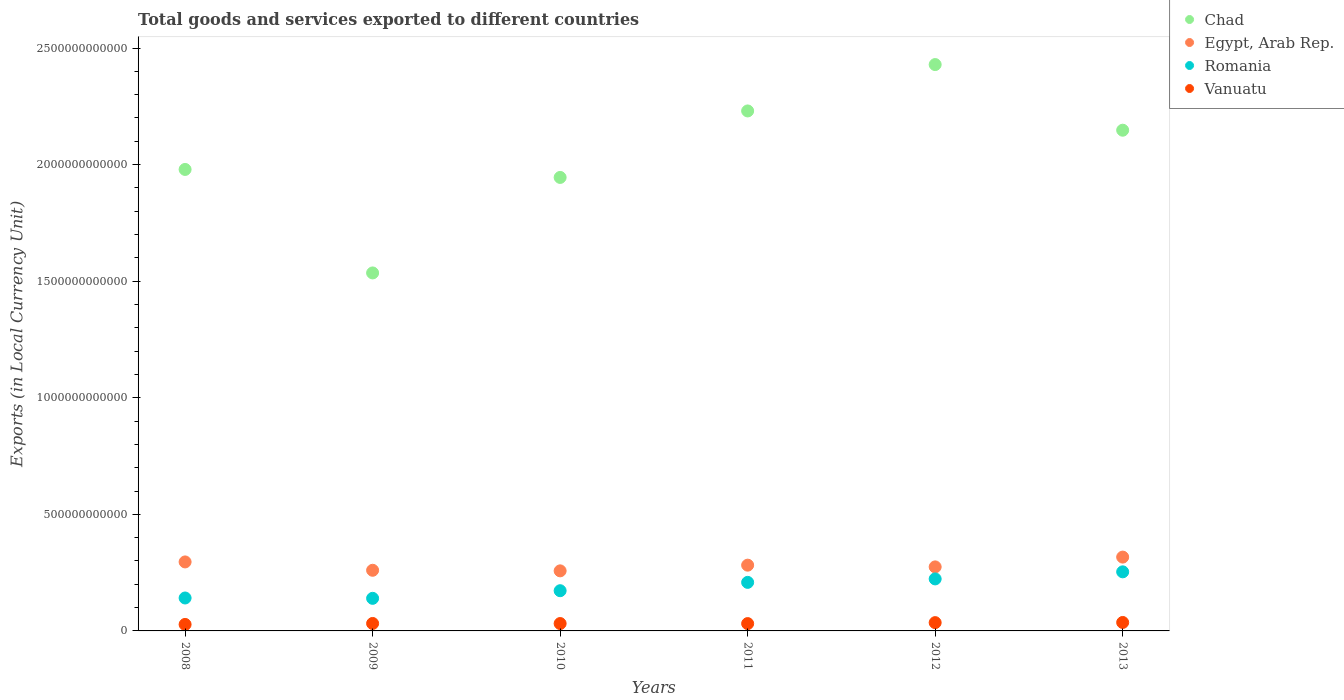How many different coloured dotlines are there?
Provide a succinct answer. 4. What is the Amount of goods and services exports in Vanuatu in 2011?
Make the answer very short. 3.14e+1. Across all years, what is the maximum Amount of goods and services exports in Egypt, Arab Rep.?
Offer a very short reply. 3.17e+11. Across all years, what is the minimum Amount of goods and services exports in Vanuatu?
Provide a succinct answer. 2.78e+1. What is the total Amount of goods and services exports in Vanuatu in the graph?
Keep it short and to the point. 1.95e+11. What is the difference between the Amount of goods and services exports in Chad in 2009 and that in 2010?
Offer a terse response. -4.10e+11. What is the difference between the Amount of goods and services exports in Egypt, Arab Rep. in 2010 and the Amount of goods and services exports in Chad in 2009?
Your answer should be compact. -1.28e+12. What is the average Amount of goods and services exports in Vanuatu per year?
Make the answer very short. 3.24e+1. In the year 2009, what is the difference between the Amount of goods and services exports in Romania and Amount of goods and services exports in Vanuatu?
Give a very brief answer. 1.08e+11. In how many years, is the Amount of goods and services exports in Vanuatu greater than 2200000000000 LCU?
Provide a short and direct response. 0. What is the ratio of the Amount of goods and services exports in Egypt, Arab Rep. in 2012 to that in 2013?
Make the answer very short. 0.87. Is the Amount of goods and services exports in Romania in 2009 less than that in 2010?
Provide a succinct answer. Yes. Is the difference between the Amount of goods and services exports in Romania in 2008 and 2010 greater than the difference between the Amount of goods and services exports in Vanuatu in 2008 and 2010?
Your answer should be very brief. No. What is the difference between the highest and the second highest Amount of goods and services exports in Vanuatu?
Make the answer very short. 7.05e+08. What is the difference between the highest and the lowest Amount of goods and services exports in Egypt, Arab Rep.?
Your answer should be compact. 5.90e+1. In how many years, is the Amount of goods and services exports in Romania greater than the average Amount of goods and services exports in Romania taken over all years?
Your response must be concise. 3. Is the sum of the Amount of goods and services exports in Romania in 2011 and 2013 greater than the maximum Amount of goods and services exports in Vanuatu across all years?
Ensure brevity in your answer.  Yes. Is it the case that in every year, the sum of the Amount of goods and services exports in Egypt, Arab Rep. and Amount of goods and services exports in Chad  is greater than the sum of Amount of goods and services exports in Vanuatu and Amount of goods and services exports in Romania?
Give a very brief answer. Yes. Is it the case that in every year, the sum of the Amount of goods and services exports in Romania and Amount of goods and services exports in Vanuatu  is greater than the Amount of goods and services exports in Egypt, Arab Rep.?
Your response must be concise. No. Does the Amount of goods and services exports in Vanuatu monotonically increase over the years?
Provide a succinct answer. No. What is the difference between two consecutive major ticks on the Y-axis?
Ensure brevity in your answer.  5.00e+11. Does the graph contain grids?
Give a very brief answer. No. Where does the legend appear in the graph?
Provide a short and direct response. Top right. How many legend labels are there?
Keep it short and to the point. 4. What is the title of the graph?
Ensure brevity in your answer.  Total goods and services exported to different countries. Does "South Asia" appear as one of the legend labels in the graph?
Ensure brevity in your answer.  No. What is the label or title of the Y-axis?
Ensure brevity in your answer.  Exports (in Local Currency Unit). What is the Exports (in Local Currency Unit) of Chad in 2008?
Offer a very short reply. 1.98e+12. What is the Exports (in Local Currency Unit) in Egypt, Arab Rep. in 2008?
Make the answer very short. 2.96e+11. What is the Exports (in Local Currency Unit) of Romania in 2008?
Provide a short and direct response. 1.41e+11. What is the Exports (in Local Currency Unit) of Vanuatu in 2008?
Ensure brevity in your answer.  2.78e+1. What is the Exports (in Local Currency Unit) in Chad in 2009?
Provide a succinct answer. 1.54e+12. What is the Exports (in Local Currency Unit) of Egypt, Arab Rep. in 2009?
Give a very brief answer. 2.60e+11. What is the Exports (in Local Currency Unit) of Romania in 2009?
Offer a terse response. 1.40e+11. What is the Exports (in Local Currency Unit) of Vanuatu in 2009?
Offer a very short reply. 3.20e+1. What is the Exports (in Local Currency Unit) of Chad in 2010?
Your response must be concise. 1.94e+12. What is the Exports (in Local Currency Unit) of Egypt, Arab Rep. in 2010?
Offer a terse response. 2.58e+11. What is the Exports (in Local Currency Unit) of Romania in 2010?
Your answer should be compact. 1.72e+11. What is the Exports (in Local Currency Unit) of Vanuatu in 2010?
Keep it short and to the point. 3.17e+1. What is the Exports (in Local Currency Unit) of Chad in 2011?
Offer a terse response. 2.23e+12. What is the Exports (in Local Currency Unit) of Egypt, Arab Rep. in 2011?
Give a very brief answer. 2.82e+11. What is the Exports (in Local Currency Unit) in Romania in 2011?
Make the answer very short. 2.08e+11. What is the Exports (in Local Currency Unit) of Vanuatu in 2011?
Keep it short and to the point. 3.14e+1. What is the Exports (in Local Currency Unit) of Chad in 2012?
Offer a terse response. 2.43e+12. What is the Exports (in Local Currency Unit) in Egypt, Arab Rep. in 2012?
Keep it short and to the point. 2.75e+11. What is the Exports (in Local Currency Unit) of Romania in 2012?
Make the answer very short. 2.23e+11. What is the Exports (in Local Currency Unit) in Vanuatu in 2012?
Give a very brief answer. 3.55e+1. What is the Exports (in Local Currency Unit) in Chad in 2013?
Provide a short and direct response. 2.15e+12. What is the Exports (in Local Currency Unit) of Egypt, Arab Rep. in 2013?
Offer a terse response. 3.17e+11. What is the Exports (in Local Currency Unit) in Romania in 2013?
Give a very brief answer. 2.53e+11. What is the Exports (in Local Currency Unit) in Vanuatu in 2013?
Provide a short and direct response. 3.63e+1. Across all years, what is the maximum Exports (in Local Currency Unit) of Chad?
Provide a succinct answer. 2.43e+12. Across all years, what is the maximum Exports (in Local Currency Unit) in Egypt, Arab Rep.?
Provide a succinct answer. 3.17e+11. Across all years, what is the maximum Exports (in Local Currency Unit) of Romania?
Offer a very short reply. 2.53e+11. Across all years, what is the maximum Exports (in Local Currency Unit) of Vanuatu?
Offer a very short reply. 3.63e+1. Across all years, what is the minimum Exports (in Local Currency Unit) in Chad?
Give a very brief answer. 1.54e+12. Across all years, what is the minimum Exports (in Local Currency Unit) of Egypt, Arab Rep.?
Your answer should be compact. 2.58e+11. Across all years, what is the minimum Exports (in Local Currency Unit) in Romania?
Provide a short and direct response. 1.40e+11. Across all years, what is the minimum Exports (in Local Currency Unit) in Vanuatu?
Make the answer very short. 2.78e+1. What is the total Exports (in Local Currency Unit) in Chad in the graph?
Ensure brevity in your answer.  1.23e+13. What is the total Exports (in Local Currency Unit) of Egypt, Arab Rep. in the graph?
Your answer should be very brief. 1.69e+12. What is the total Exports (in Local Currency Unit) of Romania in the graph?
Offer a terse response. 1.14e+12. What is the total Exports (in Local Currency Unit) of Vanuatu in the graph?
Provide a succinct answer. 1.95e+11. What is the difference between the Exports (in Local Currency Unit) in Chad in 2008 and that in 2009?
Give a very brief answer. 4.44e+11. What is the difference between the Exports (in Local Currency Unit) of Egypt, Arab Rep. in 2008 and that in 2009?
Your answer should be very brief. 3.58e+1. What is the difference between the Exports (in Local Currency Unit) in Romania in 2008 and that in 2009?
Your answer should be very brief. 1.50e+09. What is the difference between the Exports (in Local Currency Unit) in Vanuatu in 2008 and that in 2009?
Your answer should be very brief. -4.16e+09. What is the difference between the Exports (in Local Currency Unit) in Chad in 2008 and that in 2010?
Provide a succinct answer. 3.43e+1. What is the difference between the Exports (in Local Currency Unit) in Egypt, Arab Rep. in 2008 and that in 2010?
Give a very brief answer. 3.83e+1. What is the difference between the Exports (in Local Currency Unit) of Romania in 2008 and that in 2010?
Keep it short and to the point. -3.12e+1. What is the difference between the Exports (in Local Currency Unit) in Vanuatu in 2008 and that in 2010?
Offer a terse response. -3.84e+09. What is the difference between the Exports (in Local Currency Unit) in Chad in 2008 and that in 2011?
Your response must be concise. -2.51e+11. What is the difference between the Exports (in Local Currency Unit) of Egypt, Arab Rep. in 2008 and that in 2011?
Keep it short and to the point. 1.39e+1. What is the difference between the Exports (in Local Currency Unit) of Romania in 2008 and that in 2011?
Offer a terse response. -6.70e+1. What is the difference between the Exports (in Local Currency Unit) in Vanuatu in 2008 and that in 2011?
Provide a short and direct response. -3.60e+09. What is the difference between the Exports (in Local Currency Unit) in Chad in 2008 and that in 2012?
Keep it short and to the point. -4.50e+11. What is the difference between the Exports (in Local Currency Unit) in Egypt, Arab Rep. in 2008 and that in 2012?
Your answer should be very brief. 2.13e+1. What is the difference between the Exports (in Local Currency Unit) in Romania in 2008 and that in 2012?
Your answer should be compact. -8.18e+1. What is the difference between the Exports (in Local Currency Unit) in Vanuatu in 2008 and that in 2012?
Keep it short and to the point. -7.72e+09. What is the difference between the Exports (in Local Currency Unit) in Chad in 2008 and that in 2013?
Offer a terse response. -1.68e+11. What is the difference between the Exports (in Local Currency Unit) in Egypt, Arab Rep. in 2008 and that in 2013?
Your answer should be very brief. -2.07e+1. What is the difference between the Exports (in Local Currency Unit) in Romania in 2008 and that in 2013?
Give a very brief answer. -1.12e+11. What is the difference between the Exports (in Local Currency Unit) in Vanuatu in 2008 and that in 2013?
Keep it short and to the point. -8.43e+09. What is the difference between the Exports (in Local Currency Unit) in Chad in 2009 and that in 2010?
Ensure brevity in your answer.  -4.10e+11. What is the difference between the Exports (in Local Currency Unit) in Egypt, Arab Rep. in 2009 and that in 2010?
Make the answer very short. 2.50e+09. What is the difference between the Exports (in Local Currency Unit) of Romania in 2009 and that in 2010?
Keep it short and to the point. -3.27e+1. What is the difference between the Exports (in Local Currency Unit) in Vanuatu in 2009 and that in 2010?
Provide a succinct answer. 3.15e+08. What is the difference between the Exports (in Local Currency Unit) of Chad in 2009 and that in 2011?
Ensure brevity in your answer.  -6.95e+11. What is the difference between the Exports (in Local Currency Unit) of Egypt, Arab Rep. in 2009 and that in 2011?
Provide a short and direct response. -2.19e+1. What is the difference between the Exports (in Local Currency Unit) in Romania in 2009 and that in 2011?
Make the answer very short. -6.85e+1. What is the difference between the Exports (in Local Currency Unit) in Vanuatu in 2009 and that in 2011?
Keep it short and to the point. 5.55e+08. What is the difference between the Exports (in Local Currency Unit) in Chad in 2009 and that in 2012?
Ensure brevity in your answer.  -8.94e+11. What is the difference between the Exports (in Local Currency Unit) in Egypt, Arab Rep. in 2009 and that in 2012?
Your response must be concise. -1.45e+1. What is the difference between the Exports (in Local Currency Unit) in Romania in 2009 and that in 2012?
Offer a very short reply. -8.33e+1. What is the difference between the Exports (in Local Currency Unit) of Vanuatu in 2009 and that in 2012?
Your response must be concise. -3.57e+09. What is the difference between the Exports (in Local Currency Unit) in Chad in 2009 and that in 2013?
Your answer should be very brief. -6.12e+11. What is the difference between the Exports (in Local Currency Unit) in Egypt, Arab Rep. in 2009 and that in 2013?
Provide a short and direct response. -5.65e+1. What is the difference between the Exports (in Local Currency Unit) of Romania in 2009 and that in 2013?
Give a very brief answer. -1.14e+11. What is the difference between the Exports (in Local Currency Unit) in Vanuatu in 2009 and that in 2013?
Offer a terse response. -4.27e+09. What is the difference between the Exports (in Local Currency Unit) of Chad in 2010 and that in 2011?
Offer a terse response. -2.85e+11. What is the difference between the Exports (in Local Currency Unit) in Egypt, Arab Rep. in 2010 and that in 2011?
Keep it short and to the point. -2.44e+1. What is the difference between the Exports (in Local Currency Unit) in Romania in 2010 and that in 2011?
Offer a terse response. -3.58e+1. What is the difference between the Exports (in Local Currency Unit) in Vanuatu in 2010 and that in 2011?
Provide a succinct answer. 2.40e+08. What is the difference between the Exports (in Local Currency Unit) of Chad in 2010 and that in 2012?
Your response must be concise. -4.84e+11. What is the difference between the Exports (in Local Currency Unit) of Egypt, Arab Rep. in 2010 and that in 2012?
Make the answer very short. -1.70e+1. What is the difference between the Exports (in Local Currency Unit) of Romania in 2010 and that in 2012?
Give a very brief answer. -5.06e+1. What is the difference between the Exports (in Local Currency Unit) of Vanuatu in 2010 and that in 2012?
Ensure brevity in your answer.  -3.88e+09. What is the difference between the Exports (in Local Currency Unit) of Chad in 2010 and that in 2013?
Make the answer very short. -2.03e+11. What is the difference between the Exports (in Local Currency Unit) of Egypt, Arab Rep. in 2010 and that in 2013?
Give a very brief answer. -5.90e+1. What is the difference between the Exports (in Local Currency Unit) of Romania in 2010 and that in 2013?
Give a very brief answer. -8.09e+1. What is the difference between the Exports (in Local Currency Unit) of Vanuatu in 2010 and that in 2013?
Provide a succinct answer. -4.59e+09. What is the difference between the Exports (in Local Currency Unit) in Chad in 2011 and that in 2012?
Offer a terse response. -1.99e+11. What is the difference between the Exports (in Local Currency Unit) of Egypt, Arab Rep. in 2011 and that in 2012?
Your response must be concise. 7.40e+09. What is the difference between the Exports (in Local Currency Unit) of Romania in 2011 and that in 2012?
Offer a very short reply. -1.48e+1. What is the difference between the Exports (in Local Currency Unit) of Vanuatu in 2011 and that in 2012?
Offer a very short reply. -4.12e+09. What is the difference between the Exports (in Local Currency Unit) of Chad in 2011 and that in 2013?
Your response must be concise. 8.26e+1. What is the difference between the Exports (in Local Currency Unit) of Egypt, Arab Rep. in 2011 and that in 2013?
Give a very brief answer. -3.46e+1. What is the difference between the Exports (in Local Currency Unit) of Romania in 2011 and that in 2013?
Offer a very short reply. -4.52e+1. What is the difference between the Exports (in Local Currency Unit) of Vanuatu in 2011 and that in 2013?
Give a very brief answer. -4.83e+09. What is the difference between the Exports (in Local Currency Unit) in Chad in 2012 and that in 2013?
Your answer should be very brief. 2.82e+11. What is the difference between the Exports (in Local Currency Unit) in Egypt, Arab Rep. in 2012 and that in 2013?
Give a very brief answer. -4.20e+1. What is the difference between the Exports (in Local Currency Unit) in Romania in 2012 and that in 2013?
Your response must be concise. -3.03e+1. What is the difference between the Exports (in Local Currency Unit) of Vanuatu in 2012 and that in 2013?
Provide a succinct answer. -7.05e+08. What is the difference between the Exports (in Local Currency Unit) in Chad in 2008 and the Exports (in Local Currency Unit) in Egypt, Arab Rep. in 2009?
Offer a terse response. 1.72e+12. What is the difference between the Exports (in Local Currency Unit) in Chad in 2008 and the Exports (in Local Currency Unit) in Romania in 2009?
Offer a terse response. 1.84e+12. What is the difference between the Exports (in Local Currency Unit) of Chad in 2008 and the Exports (in Local Currency Unit) of Vanuatu in 2009?
Offer a terse response. 1.95e+12. What is the difference between the Exports (in Local Currency Unit) of Egypt, Arab Rep. in 2008 and the Exports (in Local Currency Unit) of Romania in 2009?
Make the answer very short. 1.56e+11. What is the difference between the Exports (in Local Currency Unit) in Egypt, Arab Rep. in 2008 and the Exports (in Local Currency Unit) in Vanuatu in 2009?
Provide a succinct answer. 2.64e+11. What is the difference between the Exports (in Local Currency Unit) in Romania in 2008 and the Exports (in Local Currency Unit) in Vanuatu in 2009?
Give a very brief answer. 1.09e+11. What is the difference between the Exports (in Local Currency Unit) in Chad in 2008 and the Exports (in Local Currency Unit) in Egypt, Arab Rep. in 2010?
Your answer should be compact. 1.72e+12. What is the difference between the Exports (in Local Currency Unit) of Chad in 2008 and the Exports (in Local Currency Unit) of Romania in 2010?
Make the answer very short. 1.81e+12. What is the difference between the Exports (in Local Currency Unit) of Chad in 2008 and the Exports (in Local Currency Unit) of Vanuatu in 2010?
Provide a succinct answer. 1.95e+12. What is the difference between the Exports (in Local Currency Unit) of Egypt, Arab Rep. in 2008 and the Exports (in Local Currency Unit) of Romania in 2010?
Offer a terse response. 1.23e+11. What is the difference between the Exports (in Local Currency Unit) in Egypt, Arab Rep. in 2008 and the Exports (in Local Currency Unit) in Vanuatu in 2010?
Provide a succinct answer. 2.64e+11. What is the difference between the Exports (in Local Currency Unit) in Romania in 2008 and the Exports (in Local Currency Unit) in Vanuatu in 2010?
Give a very brief answer. 1.10e+11. What is the difference between the Exports (in Local Currency Unit) in Chad in 2008 and the Exports (in Local Currency Unit) in Egypt, Arab Rep. in 2011?
Offer a terse response. 1.70e+12. What is the difference between the Exports (in Local Currency Unit) of Chad in 2008 and the Exports (in Local Currency Unit) of Romania in 2011?
Offer a terse response. 1.77e+12. What is the difference between the Exports (in Local Currency Unit) of Chad in 2008 and the Exports (in Local Currency Unit) of Vanuatu in 2011?
Provide a succinct answer. 1.95e+12. What is the difference between the Exports (in Local Currency Unit) in Egypt, Arab Rep. in 2008 and the Exports (in Local Currency Unit) in Romania in 2011?
Ensure brevity in your answer.  8.77e+1. What is the difference between the Exports (in Local Currency Unit) in Egypt, Arab Rep. in 2008 and the Exports (in Local Currency Unit) in Vanuatu in 2011?
Your response must be concise. 2.64e+11. What is the difference between the Exports (in Local Currency Unit) of Romania in 2008 and the Exports (in Local Currency Unit) of Vanuatu in 2011?
Give a very brief answer. 1.10e+11. What is the difference between the Exports (in Local Currency Unit) in Chad in 2008 and the Exports (in Local Currency Unit) in Egypt, Arab Rep. in 2012?
Provide a short and direct response. 1.70e+12. What is the difference between the Exports (in Local Currency Unit) of Chad in 2008 and the Exports (in Local Currency Unit) of Romania in 2012?
Make the answer very short. 1.76e+12. What is the difference between the Exports (in Local Currency Unit) in Chad in 2008 and the Exports (in Local Currency Unit) in Vanuatu in 2012?
Provide a succinct answer. 1.94e+12. What is the difference between the Exports (in Local Currency Unit) in Egypt, Arab Rep. in 2008 and the Exports (in Local Currency Unit) in Romania in 2012?
Your answer should be very brief. 7.29e+1. What is the difference between the Exports (in Local Currency Unit) of Egypt, Arab Rep. in 2008 and the Exports (in Local Currency Unit) of Vanuatu in 2012?
Offer a very short reply. 2.60e+11. What is the difference between the Exports (in Local Currency Unit) of Romania in 2008 and the Exports (in Local Currency Unit) of Vanuatu in 2012?
Your answer should be compact. 1.06e+11. What is the difference between the Exports (in Local Currency Unit) in Chad in 2008 and the Exports (in Local Currency Unit) in Egypt, Arab Rep. in 2013?
Your answer should be very brief. 1.66e+12. What is the difference between the Exports (in Local Currency Unit) in Chad in 2008 and the Exports (in Local Currency Unit) in Romania in 2013?
Provide a succinct answer. 1.73e+12. What is the difference between the Exports (in Local Currency Unit) in Chad in 2008 and the Exports (in Local Currency Unit) in Vanuatu in 2013?
Give a very brief answer. 1.94e+12. What is the difference between the Exports (in Local Currency Unit) of Egypt, Arab Rep. in 2008 and the Exports (in Local Currency Unit) of Romania in 2013?
Offer a terse response. 4.25e+1. What is the difference between the Exports (in Local Currency Unit) of Egypt, Arab Rep. in 2008 and the Exports (in Local Currency Unit) of Vanuatu in 2013?
Your answer should be compact. 2.60e+11. What is the difference between the Exports (in Local Currency Unit) of Romania in 2008 and the Exports (in Local Currency Unit) of Vanuatu in 2013?
Give a very brief answer. 1.05e+11. What is the difference between the Exports (in Local Currency Unit) in Chad in 2009 and the Exports (in Local Currency Unit) in Egypt, Arab Rep. in 2010?
Provide a succinct answer. 1.28e+12. What is the difference between the Exports (in Local Currency Unit) in Chad in 2009 and the Exports (in Local Currency Unit) in Romania in 2010?
Give a very brief answer. 1.36e+12. What is the difference between the Exports (in Local Currency Unit) of Chad in 2009 and the Exports (in Local Currency Unit) of Vanuatu in 2010?
Keep it short and to the point. 1.50e+12. What is the difference between the Exports (in Local Currency Unit) in Egypt, Arab Rep. in 2009 and the Exports (in Local Currency Unit) in Romania in 2010?
Give a very brief answer. 8.76e+1. What is the difference between the Exports (in Local Currency Unit) of Egypt, Arab Rep. in 2009 and the Exports (in Local Currency Unit) of Vanuatu in 2010?
Give a very brief answer. 2.28e+11. What is the difference between the Exports (in Local Currency Unit) of Romania in 2009 and the Exports (in Local Currency Unit) of Vanuatu in 2010?
Offer a terse response. 1.08e+11. What is the difference between the Exports (in Local Currency Unit) of Chad in 2009 and the Exports (in Local Currency Unit) of Egypt, Arab Rep. in 2011?
Offer a terse response. 1.25e+12. What is the difference between the Exports (in Local Currency Unit) of Chad in 2009 and the Exports (in Local Currency Unit) of Romania in 2011?
Your answer should be very brief. 1.33e+12. What is the difference between the Exports (in Local Currency Unit) of Chad in 2009 and the Exports (in Local Currency Unit) of Vanuatu in 2011?
Your answer should be compact. 1.50e+12. What is the difference between the Exports (in Local Currency Unit) in Egypt, Arab Rep. in 2009 and the Exports (in Local Currency Unit) in Romania in 2011?
Give a very brief answer. 5.19e+1. What is the difference between the Exports (in Local Currency Unit) in Egypt, Arab Rep. in 2009 and the Exports (in Local Currency Unit) in Vanuatu in 2011?
Your answer should be compact. 2.29e+11. What is the difference between the Exports (in Local Currency Unit) of Romania in 2009 and the Exports (in Local Currency Unit) of Vanuatu in 2011?
Your answer should be compact. 1.08e+11. What is the difference between the Exports (in Local Currency Unit) of Chad in 2009 and the Exports (in Local Currency Unit) of Egypt, Arab Rep. in 2012?
Provide a succinct answer. 1.26e+12. What is the difference between the Exports (in Local Currency Unit) of Chad in 2009 and the Exports (in Local Currency Unit) of Romania in 2012?
Offer a terse response. 1.31e+12. What is the difference between the Exports (in Local Currency Unit) of Chad in 2009 and the Exports (in Local Currency Unit) of Vanuatu in 2012?
Keep it short and to the point. 1.50e+12. What is the difference between the Exports (in Local Currency Unit) in Egypt, Arab Rep. in 2009 and the Exports (in Local Currency Unit) in Romania in 2012?
Offer a terse response. 3.71e+1. What is the difference between the Exports (in Local Currency Unit) of Egypt, Arab Rep. in 2009 and the Exports (in Local Currency Unit) of Vanuatu in 2012?
Your response must be concise. 2.25e+11. What is the difference between the Exports (in Local Currency Unit) of Romania in 2009 and the Exports (in Local Currency Unit) of Vanuatu in 2012?
Keep it short and to the point. 1.04e+11. What is the difference between the Exports (in Local Currency Unit) of Chad in 2009 and the Exports (in Local Currency Unit) of Egypt, Arab Rep. in 2013?
Make the answer very short. 1.22e+12. What is the difference between the Exports (in Local Currency Unit) in Chad in 2009 and the Exports (in Local Currency Unit) in Romania in 2013?
Give a very brief answer. 1.28e+12. What is the difference between the Exports (in Local Currency Unit) in Chad in 2009 and the Exports (in Local Currency Unit) in Vanuatu in 2013?
Provide a succinct answer. 1.50e+12. What is the difference between the Exports (in Local Currency Unit) in Egypt, Arab Rep. in 2009 and the Exports (in Local Currency Unit) in Romania in 2013?
Ensure brevity in your answer.  6.72e+09. What is the difference between the Exports (in Local Currency Unit) in Egypt, Arab Rep. in 2009 and the Exports (in Local Currency Unit) in Vanuatu in 2013?
Your answer should be very brief. 2.24e+11. What is the difference between the Exports (in Local Currency Unit) of Romania in 2009 and the Exports (in Local Currency Unit) of Vanuatu in 2013?
Provide a succinct answer. 1.03e+11. What is the difference between the Exports (in Local Currency Unit) in Chad in 2010 and the Exports (in Local Currency Unit) in Egypt, Arab Rep. in 2011?
Offer a very short reply. 1.66e+12. What is the difference between the Exports (in Local Currency Unit) in Chad in 2010 and the Exports (in Local Currency Unit) in Romania in 2011?
Give a very brief answer. 1.74e+12. What is the difference between the Exports (in Local Currency Unit) of Chad in 2010 and the Exports (in Local Currency Unit) of Vanuatu in 2011?
Provide a succinct answer. 1.91e+12. What is the difference between the Exports (in Local Currency Unit) in Egypt, Arab Rep. in 2010 and the Exports (in Local Currency Unit) in Romania in 2011?
Your answer should be very brief. 4.94e+1. What is the difference between the Exports (in Local Currency Unit) in Egypt, Arab Rep. in 2010 and the Exports (in Local Currency Unit) in Vanuatu in 2011?
Ensure brevity in your answer.  2.26e+11. What is the difference between the Exports (in Local Currency Unit) in Romania in 2010 and the Exports (in Local Currency Unit) in Vanuatu in 2011?
Your answer should be compact. 1.41e+11. What is the difference between the Exports (in Local Currency Unit) of Chad in 2010 and the Exports (in Local Currency Unit) of Egypt, Arab Rep. in 2012?
Offer a very short reply. 1.67e+12. What is the difference between the Exports (in Local Currency Unit) in Chad in 2010 and the Exports (in Local Currency Unit) in Romania in 2012?
Provide a succinct answer. 1.72e+12. What is the difference between the Exports (in Local Currency Unit) of Chad in 2010 and the Exports (in Local Currency Unit) of Vanuatu in 2012?
Your answer should be compact. 1.91e+12. What is the difference between the Exports (in Local Currency Unit) of Egypt, Arab Rep. in 2010 and the Exports (in Local Currency Unit) of Romania in 2012?
Provide a short and direct response. 3.46e+1. What is the difference between the Exports (in Local Currency Unit) in Egypt, Arab Rep. in 2010 and the Exports (in Local Currency Unit) in Vanuatu in 2012?
Ensure brevity in your answer.  2.22e+11. What is the difference between the Exports (in Local Currency Unit) of Romania in 2010 and the Exports (in Local Currency Unit) of Vanuatu in 2012?
Your answer should be very brief. 1.37e+11. What is the difference between the Exports (in Local Currency Unit) of Chad in 2010 and the Exports (in Local Currency Unit) of Egypt, Arab Rep. in 2013?
Keep it short and to the point. 1.63e+12. What is the difference between the Exports (in Local Currency Unit) of Chad in 2010 and the Exports (in Local Currency Unit) of Romania in 2013?
Give a very brief answer. 1.69e+12. What is the difference between the Exports (in Local Currency Unit) in Chad in 2010 and the Exports (in Local Currency Unit) in Vanuatu in 2013?
Make the answer very short. 1.91e+12. What is the difference between the Exports (in Local Currency Unit) in Egypt, Arab Rep. in 2010 and the Exports (in Local Currency Unit) in Romania in 2013?
Your response must be concise. 4.22e+09. What is the difference between the Exports (in Local Currency Unit) in Egypt, Arab Rep. in 2010 and the Exports (in Local Currency Unit) in Vanuatu in 2013?
Offer a terse response. 2.21e+11. What is the difference between the Exports (in Local Currency Unit) of Romania in 2010 and the Exports (in Local Currency Unit) of Vanuatu in 2013?
Offer a very short reply. 1.36e+11. What is the difference between the Exports (in Local Currency Unit) of Chad in 2011 and the Exports (in Local Currency Unit) of Egypt, Arab Rep. in 2012?
Give a very brief answer. 1.96e+12. What is the difference between the Exports (in Local Currency Unit) in Chad in 2011 and the Exports (in Local Currency Unit) in Romania in 2012?
Your answer should be very brief. 2.01e+12. What is the difference between the Exports (in Local Currency Unit) in Chad in 2011 and the Exports (in Local Currency Unit) in Vanuatu in 2012?
Ensure brevity in your answer.  2.19e+12. What is the difference between the Exports (in Local Currency Unit) of Egypt, Arab Rep. in 2011 and the Exports (in Local Currency Unit) of Romania in 2012?
Provide a short and direct response. 5.90e+1. What is the difference between the Exports (in Local Currency Unit) in Egypt, Arab Rep. in 2011 and the Exports (in Local Currency Unit) in Vanuatu in 2012?
Provide a short and direct response. 2.46e+11. What is the difference between the Exports (in Local Currency Unit) in Romania in 2011 and the Exports (in Local Currency Unit) in Vanuatu in 2012?
Your answer should be very brief. 1.73e+11. What is the difference between the Exports (in Local Currency Unit) in Chad in 2011 and the Exports (in Local Currency Unit) in Egypt, Arab Rep. in 2013?
Offer a terse response. 1.91e+12. What is the difference between the Exports (in Local Currency Unit) of Chad in 2011 and the Exports (in Local Currency Unit) of Romania in 2013?
Ensure brevity in your answer.  1.98e+12. What is the difference between the Exports (in Local Currency Unit) in Chad in 2011 and the Exports (in Local Currency Unit) in Vanuatu in 2013?
Your answer should be compact. 2.19e+12. What is the difference between the Exports (in Local Currency Unit) in Egypt, Arab Rep. in 2011 and the Exports (in Local Currency Unit) in Romania in 2013?
Give a very brief answer. 2.86e+1. What is the difference between the Exports (in Local Currency Unit) of Egypt, Arab Rep. in 2011 and the Exports (in Local Currency Unit) of Vanuatu in 2013?
Provide a short and direct response. 2.46e+11. What is the difference between the Exports (in Local Currency Unit) in Romania in 2011 and the Exports (in Local Currency Unit) in Vanuatu in 2013?
Ensure brevity in your answer.  1.72e+11. What is the difference between the Exports (in Local Currency Unit) of Chad in 2012 and the Exports (in Local Currency Unit) of Egypt, Arab Rep. in 2013?
Give a very brief answer. 2.11e+12. What is the difference between the Exports (in Local Currency Unit) in Chad in 2012 and the Exports (in Local Currency Unit) in Romania in 2013?
Make the answer very short. 2.18e+12. What is the difference between the Exports (in Local Currency Unit) in Chad in 2012 and the Exports (in Local Currency Unit) in Vanuatu in 2013?
Your answer should be compact. 2.39e+12. What is the difference between the Exports (in Local Currency Unit) in Egypt, Arab Rep. in 2012 and the Exports (in Local Currency Unit) in Romania in 2013?
Your answer should be compact. 2.12e+1. What is the difference between the Exports (in Local Currency Unit) in Egypt, Arab Rep. in 2012 and the Exports (in Local Currency Unit) in Vanuatu in 2013?
Your answer should be very brief. 2.38e+11. What is the difference between the Exports (in Local Currency Unit) in Romania in 2012 and the Exports (in Local Currency Unit) in Vanuatu in 2013?
Your response must be concise. 1.87e+11. What is the average Exports (in Local Currency Unit) in Chad per year?
Your answer should be very brief. 2.04e+12. What is the average Exports (in Local Currency Unit) of Egypt, Arab Rep. per year?
Provide a succinct answer. 2.81e+11. What is the average Exports (in Local Currency Unit) in Romania per year?
Provide a short and direct response. 1.90e+11. What is the average Exports (in Local Currency Unit) in Vanuatu per year?
Your answer should be compact. 3.24e+1. In the year 2008, what is the difference between the Exports (in Local Currency Unit) in Chad and Exports (in Local Currency Unit) in Egypt, Arab Rep.?
Provide a short and direct response. 1.68e+12. In the year 2008, what is the difference between the Exports (in Local Currency Unit) of Chad and Exports (in Local Currency Unit) of Romania?
Offer a terse response. 1.84e+12. In the year 2008, what is the difference between the Exports (in Local Currency Unit) of Chad and Exports (in Local Currency Unit) of Vanuatu?
Your response must be concise. 1.95e+12. In the year 2008, what is the difference between the Exports (in Local Currency Unit) in Egypt, Arab Rep. and Exports (in Local Currency Unit) in Romania?
Offer a very short reply. 1.55e+11. In the year 2008, what is the difference between the Exports (in Local Currency Unit) of Egypt, Arab Rep. and Exports (in Local Currency Unit) of Vanuatu?
Offer a terse response. 2.68e+11. In the year 2008, what is the difference between the Exports (in Local Currency Unit) in Romania and Exports (in Local Currency Unit) in Vanuatu?
Keep it short and to the point. 1.13e+11. In the year 2009, what is the difference between the Exports (in Local Currency Unit) of Chad and Exports (in Local Currency Unit) of Egypt, Arab Rep.?
Give a very brief answer. 1.28e+12. In the year 2009, what is the difference between the Exports (in Local Currency Unit) of Chad and Exports (in Local Currency Unit) of Romania?
Keep it short and to the point. 1.40e+12. In the year 2009, what is the difference between the Exports (in Local Currency Unit) of Chad and Exports (in Local Currency Unit) of Vanuatu?
Offer a very short reply. 1.50e+12. In the year 2009, what is the difference between the Exports (in Local Currency Unit) of Egypt, Arab Rep. and Exports (in Local Currency Unit) of Romania?
Ensure brevity in your answer.  1.20e+11. In the year 2009, what is the difference between the Exports (in Local Currency Unit) in Egypt, Arab Rep. and Exports (in Local Currency Unit) in Vanuatu?
Your answer should be very brief. 2.28e+11. In the year 2009, what is the difference between the Exports (in Local Currency Unit) in Romania and Exports (in Local Currency Unit) in Vanuatu?
Make the answer very short. 1.08e+11. In the year 2010, what is the difference between the Exports (in Local Currency Unit) in Chad and Exports (in Local Currency Unit) in Egypt, Arab Rep.?
Ensure brevity in your answer.  1.69e+12. In the year 2010, what is the difference between the Exports (in Local Currency Unit) of Chad and Exports (in Local Currency Unit) of Romania?
Your response must be concise. 1.77e+12. In the year 2010, what is the difference between the Exports (in Local Currency Unit) of Chad and Exports (in Local Currency Unit) of Vanuatu?
Your response must be concise. 1.91e+12. In the year 2010, what is the difference between the Exports (in Local Currency Unit) in Egypt, Arab Rep. and Exports (in Local Currency Unit) in Romania?
Ensure brevity in your answer.  8.51e+1. In the year 2010, what is the difference between the Exports (in Local Currency Unit) in Egypt, Arab Rep. and Exports (in Local Currency Unit) in Vanuatu?
Your answer should be very brief. 2.26e+11. In the year 2010, what is the difference between the Exports (in Local Currency Unit) in Romania and Exports (in Local Currency Unit) in Vanuatu?
Keep it short and to the point. 1.41e+11. In the year 2011, what is the difference between the Exports (in Local Currency Unit) of Chad and Exports (in Local Currency Unit) of Egypt, Arab Rep.?
Offer a terse response. 1.95e+12. In the year 2011, what is the difference between the Exports (in Local Currency Unit) of Chad and Exports (in Local Currency Unit) of Romania?
Offer a very short reply. 2.02e+12. In the year 2011, what is the difference between the Exports (in Local Currency Unit) of Chad and Exports (in Local Currency Unit) of Vanuatu?
Provide a succinct answer. 2.20e+12. In the year 2011, what is the difference between the Exports (in Local Currency Unit) in Egypt, Arab Rep. and Exports (in Local Currency Unit) in Romania?
Provide a short and direct response. 7.38e+1. In the year 2011, what is the difference between the Exports (in Local Currency Unit) in Egypt, Arab Rep. and Exports (in Local Currency Unit) in Vanuatu?
Give a very brief answer. 2.51e+11. In the year 2011, what is the difference between the Exports (in Local Currency Unit) in Romania and Exports (in Local Currency Unit) in Vanuatu?
Your answer should be compact. 1.77e+11. In the year 2012, what is the difference between the Exports (in Local Currency Unit) of Chad and Exports (in Local Currency Unit) of Egypt, Arab Rep.?
Offer a terse response. 2.15e+12. In the year 2012, what is the difference between the Exports (in Local Currency Unit) of Chad and Exports (in Local Currency Unit) of Romania?
Offer a terse response. 2.21e+12. In the year 2012, what is the difference between the Exports (in Local Currency Unit) of Chad and Exports (in Local Currency Unit) of Vanuatu?
Keep it short and to the point. 2.39e+12. In the year 2012, what is the difference between the Exports (in Local Currency Unit) of Egypt, Arab Rep. and Exports (in Local Currency Unit) of Romania?
Your answer should be compact. 5.16e+1. In the year 2012, what is the difference between the Exports (in Local Currency Unit) of Egypt, Arab Rep. and Exports (in Local Currency Unit) of Vanuatu?
Your answer should be very brief. 2.39e+11. In the year 2012, what is the difference between the Exports (in Local Currency Unit) in Romania and Exports (in Local Currency Unit) in Vanuatu?
Make the answer very short. 1.87e+11. In the year 2013, what is the difference between the Exports (in Local Currency Unit) of Chad and Exports (in Local Currency Unit) of Egypt, Arab Rep.?
Provide a succinct answer. 1.83e+12. In the year 2013, what is the difference between the Exports (in Local Currency Unit) of Chad and Exports (in Local Currency Unit) of Romania?
Give a very brief answer. 1.89e+12. In the year 2013, what is the difference between the Exports (in Local Currency Unit) in Chad and Exports (in Local Currency Unit) in Vanuatu?
Provide a succinct answer. 2.11e+12. In the year 2013, what is the difference between the Exports (in Local Currency Unit) of Egypt, Arab Rep. and Exports (in Local Currency Unit) of Romania?
Your response must be concise. 6.32e+1. In the year 2013, what is the difference between the Exports (in Local Currency Unit) in Egypt, Arab Rep. and Exports (in Local Currency Unit) in Vanuatu?
Give a very brief answer. 2.80e+11. In the year 2013, what is the difference between the Exports (in Local Currency Unit) in Romania and Exports (in Local Currency Unit) in Vanuatu?
Make the answer very short. 2.17e+11. What is the ratio of the Exports (in Local Currency Unit) of Chad in 2008 to that in 2009?
Offer a terse response. 1.29. What is the ratio of the Exports (in Local Currency Unit) in Egypt, Arab Rep. in 2008 to that in 2009?
Your answer should be very brief. 1.14. What is the ratio of the Exports (in Local Currency Unit) of Romania in 2008 to that in 2009?
Your answer should be compact. 1.01. What is the ratio of the Exports (in Local Currency Unit) of Vanuatu in 2008 to that in 2009?
Ensure brevity in your answer.  0.87. What is the ratio of the Exports (in Local Currency Unit) in Chad in 2008 to that in 2010?
Offer a very short reply. 1.02. What is the ratio of the Exports (in Local Currency Unit) of Egypt, Arab Rep. in 2008 to that in 2010?
Make the answer very short. 1.15. What is the ratio of the Exports (in Local Currency Unit) of Romania in 2008 to that in 2010?
Ensure brevity in your answer.  0.82. What is the ratio of the Exports (in Local Currency Unit) in Vanuatu in 2008 to that in 2010?
Your answer should be compact. 0.88. What is the ratio of the Exports (in Local Currency Unit) in Chad in 2008 to that in 2011?
Provide a succinct answer. 0.89. What is the ratio of the Exports (in Local Currency Unit) of Egypt, Arab Rep. in 2008 to that in 2011?
Provide a succinct answer. 1.05. What is the ratio of the Exports (in Local Currency Unit) of Romania in 2008 to that in 2011?
Your answer should be very brief. 0.68. What is the ratio of the Exports (in Local Currency Unit) of Vanuatu in 2008 to that in 2011?
Your response must be concise. 0.89. What is the ratio of the Exports (in Local Currency Unit) of Chad in 2008 to that in 2012?
Provide a succinct answer. 0.81. What is the ratio of the Exports (in Local Currency Unit) of Egypt, Arab Rep. in 2008 to that in 2012?
Ensure brevity in your answer.  1.08. What is the ratio of the Exports (in Local Currency Unit) in Romania in 2008 to that in 2012?
Your answer should be compact. 0.63. What is the ratio of the Exports (in Local Currency Unit) in Vanuatu in 2008 to that in 2012?
Ensure brevity in your answer.  0.78. What is the ratio of the Exports (in Local Currency Unit) in Chad in 2008 to that in 2013?
Offer a very short reply. 0.92. What is the ratio of the Exports (in Local Currency Unit) of Egypt, Arab Rep. in 2008 to that in 2013?
Ensure brevity in your answer.  0.93. What is the ratio of the Exports (in Local Currency Unit) of Romania in 2008 to that in 2013?
Offer a terse response. 0.56. What is the ratio of the Exports (in Local Currency Unit) in Vanuatu in 2008 to that in 2013?
Provide a short and direct response. 0.77. What is the ratio of the Exports (in Local Currency Unit) in Chad in 2009 to that in 2010?
Keep it short and to the point. 0.79. What is the ratio of the Exports (in Local Currency Unit) of Egypt, Arab Rep. in 2009 to that in 2010?
Offer a very short reply. 1.01. What is the ratio of the Exports (in Local Currency Unit) of Romania in 2009 to that in 2010?
Offer a very short reply. 0.81. What is the ratio of the Exports (in Local Currency Unit) of Vanuatu in 2009 to that in 2010?
Provide a succinct answer. 1.01. What is the ratio of the Exports (in Local Currency Unit) of Chad in 2009 to that in 2011?
Provide a succinct answer. 0.69. What is the ratio of the Exports (in Local Currency Unit) of Egypt, Arab Rep. in 2009 to that in 2011?
Ensure brevity in your answer.  0.92. What is the ratio of the Exports (in Local Currency Unit) in Romania in 2009 to that in 2011?
Provide a succinct answer. 0.67. What is the ratio of the Exports (in Local Currency Unit) in Vanuatu in 2009 to that in 2011?
Keep it short and to the point. 1.02. What is the ratio of the Exports (in Local Currency Unit) in Chad in 2009 to that in 2012?
Make the answer very short. 0.63. What is the ratio of the Exports (in Local Currency Unit) of Egypt, Arab Rep. in 2009 to that in 2012?
Keep it short and to the point. 0.95. What is the ratio of the Exports (in Local Currency Unit) in Romania in 2009 to that in 2012?
Give a very brief answer. 0.63. What is the ratio of the Exports (in Local Currency Unit) in Vanuatu in 2009 to that in 2012?
Offer a terse response. 0.9. What is the ratio of the Exports (in Local Currency Unit) in Chad in 2009 to that in 2013?
Make the answer very short. 0.71. What is the ratio of the Exports (in Local Currency Unit) of Egypt, Arab Rep. in 2009 to that in 2013?
Your answer should be compact. 0.82. What is the ratio of the Exports (in Local Currency Unit) of Romania in 2009 to that in 2013?
Offer a very short reply. 0.55. What is the ratio of the Exports (in Local Currency Unit) in Vanuatu in 2009 to that in 2013?
Your response must be concise. 0.88. What is the ratio of the Exports (in Local Currency Unit) in Chad in 2010 to that in 2011?
Provide a succinct answer. 0.87. What is the ratio of the Exports (in Local Currency Unit) in Egypt, Arab Rep. in 2010 to that in 2011?
Ensure brevity in your answer.  0.91. What is the ratio of the Exports (in Local Currency Unit) of Romania in 2010 to that in 2011?
Your answer should be very brief. 0.83. What is the ratio of the Exports (in Local Currency Unit) of Vanuatu in 2010 to that in 2011?
Ensure brevity in your answer.  1.01. What is the ratio of the Exports (in Local Currency Unit) of Chad in 2010 to that in 2012?
Provide a succinct answer. 0.8. What is the ratio of the Exports (in Local Currency Unit) in Egypt, Arab Rep. in 2010 to that in 2012?
Make the answer very short. 0.94. What is the ratio of the Exports (in Local Currency Unit) of Romania in 2010 to that in 2012?
Offer a very short reply. 0.77. What is the ratio of the Exports (in Local Currency Unit) in Vanuatu in 2010 to that in 2012?
Offer a terse response. 0.89. What is the ratio of the Exports (in Local Currency Unit) of Chad in 2010 to that in 2013?
Provide a succinct answer. 0.91. What is the ratio of the Exports (in Local Currency Unit) in Egypt, Arab Rep. in 2010 to that in 2013?
Keep it short and to the point. 0.81. What is the ratio of the Exports (in Local Currency Unit) in Romania in 2010 to that in 2013?
Keep it short and to the point. 0.68. What is the ratio of the Exports (in Local Currency Unit) of Vanuatu in 2010 to that in 2013?
Keep it short and to the point. 0.87. What is the ratio of the Exports (in Local Currency Unit) of Chad in 2011 to that in 2012?
Ensure brevity in your answer.  0.92. What is the ratio of the Exports (in Local Currency Unit) in Egypt, Arab Rep. in 2011 to that in 2012?
Ensure brevity in your answer.  1.03. What is the ratio of the Exports (in Local Currency Unit) in Romania in 2011 to that in 2012?
Your response must be concise. 0.93. What is the ratio of the Exports (in Local Currency Unit) in Vanuatu in 2011 to that in 2012?
Ensure brevity in your answer.  0.88. What is the ratio of the Exports (in Local Currency Unit) in Egypt, Arab Rep. in 2011 to that in 2013?
Offer a terse response. 0.89. What is the ratio of the Exports (in Local Currency Unit) of Romania in 2011 to that in 2013?
Provide a short and direct response. 0.82. What is the ratio of the Exports (in Local Currency Unit) of Vanuatu in 2011 to that in 2013?
Your answer should be very brief. 0.87. What is the ratio of the Exports (in Local Currency Unit) in Chad in 2012 to that in 2013?
Ensure brevity in your answer.  1.13. What is the ratio of the Exports (in Local Currency Unit) of Egypt, Arab Rep. in 2012 to that in 2013?
Make the answer very short. 0.87. What is the ratio of the Exports (in Local Currency Unit) in Romania in 2012 to that in 2013?
Provide a short and direct response. 0.88. What is the ratio of the Exports (in Local Currency Unit) in Vanuatu in 2012 to that in 2013?
Your answer should be compact. 0.98. What is the difference between the highest and the second highest Exports (in Local Currency Unit) of Chad?
Give a very brief answer. 1.99e+11. What is the difference between the highest and the second highest Exports (in Local Currency Unit) in Egypt, Arab Rep.?
Provide a short and direct response. 2.07e+1. What is the difference between the highest and the second highest Exports (in Local Currency Unit) of Romania?
Your answer should be very brief. 3.03e+1. What is the difference between the highest and the second highest Exports (in Local Currency Unit) in Vanuatu?
Your answer should be compact. 7.05e+08. What is the difference between the highest and the lowest Exports (in Local Currency Unit) in Chad?
Provide a short and direct response. 8.94e+11. What is the difference between the highest and the lowest Exports (in Local Currency Unit) of Egypt, Arab Rep.?
Keep it short and to the point. 5.90e+1. What is the difference between the highest and the lowest Exports (in Local Currency Unit) in Romania?
Give a very brief answer. 1.14e+11. What is the difference between the highest and the lowest Exports (in Local Currency Unit) in Vanuatu?
Your answer should be compact. 8.43e+09. 